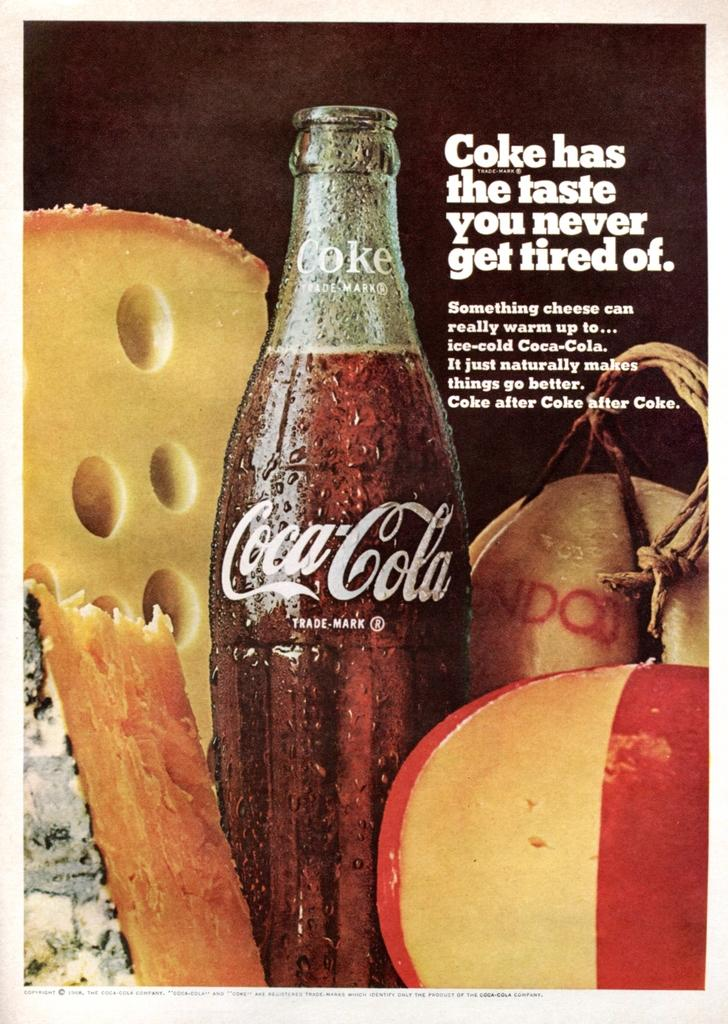What is the main object in the middle of the image? There is a coke bottle in the middle of the image. What type of food is located in the top left corner of the image? There is cheese in the top left corner of the image. What can be seen in the right bottom corner of the image? There is food in the right bottom corner of the image. What is written in the top right corner of the image? There is text written in the top right corner of the image. What is the weight of the peace symbol in the image? There is no peace symbol present in the image, so it is not possible to determine its weight. 